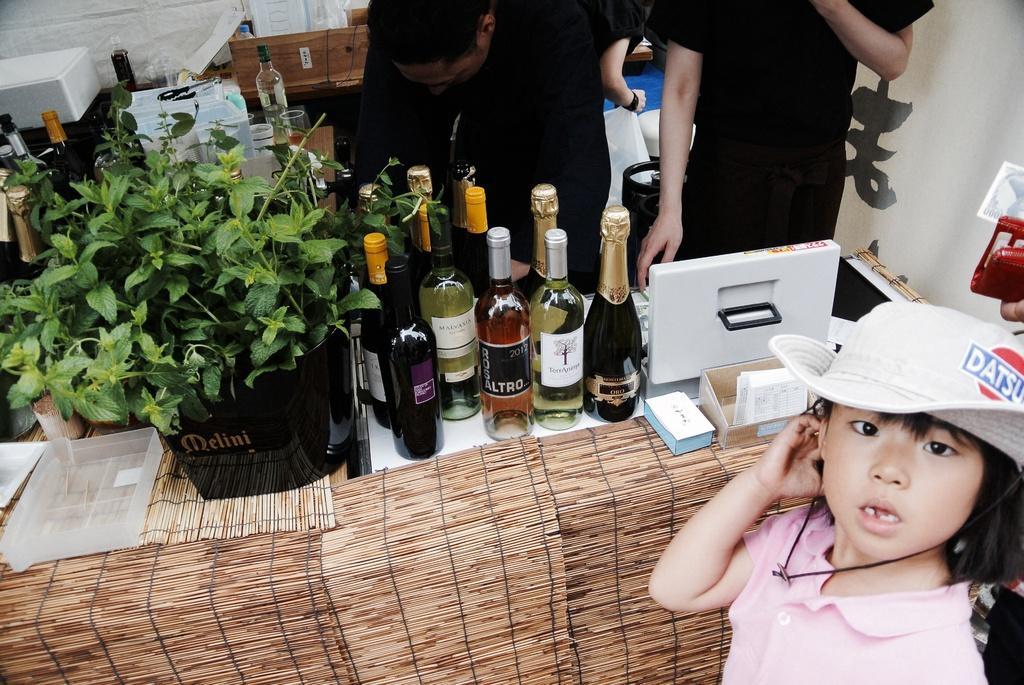In one or two sentences, can you explain what this image depicts? In the image we can see there is a girl who is standing and wearing white colour cap and on the table there are wine bottles and few people are standing at the back. 